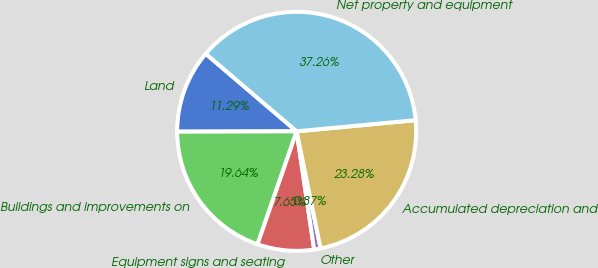Convert chart to OTSL. <chart><loc_0><loc_0><loc_500><loc_500><pie_chart><fcel>Land<fcel>Buildings and improvements on<fcel>Equipment signs and seating<fcel>Other<fcel>Accumulated depreciation and<fcel>Net property and equipment<nl><fcel>11.29%<fcel>19.64%<fcel>7.65%<fcel>0.87%<fcel>23.28%<fcel>37.26%<nl></chart> 